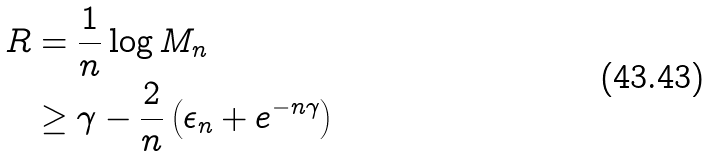<formula> <loc_0><loc_0><loc_500><loc_500>R & = \frac { 1 } { n } \log M _ { n } \\ & \geq \gamma - \frac { 2 } { n } \left ( \epsilon _ { n } + e ^ { - n \gamma } \right )</formula> 